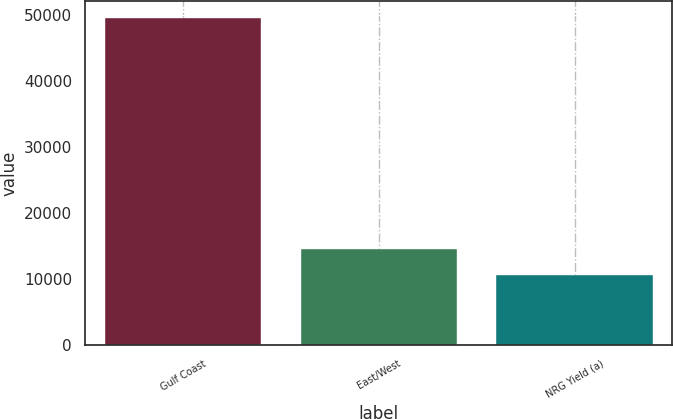<chart> <loc_0><loc_0><loc_500><loc_500><bar_chart><fcel>Gulf Coast<fcel>East/West<fcel>NRG Yield (a)<nl><fcel>49573<fcel>14574.7<fcel>10686<nl></chart> 